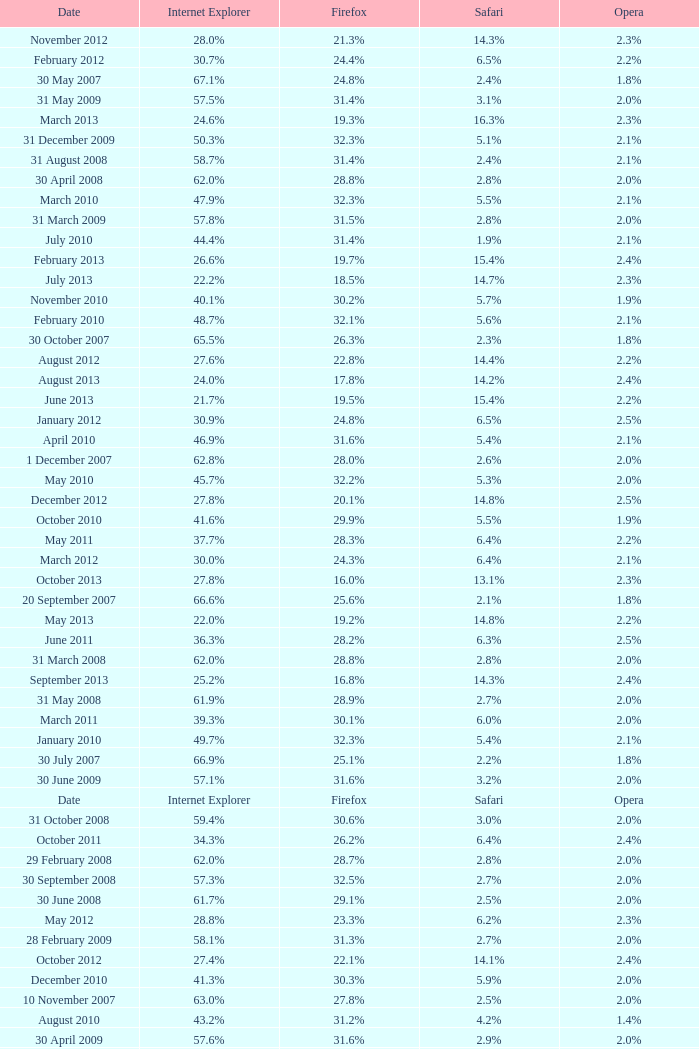What is the firefox value with a 22.0% internet explorer? 19.2%. 